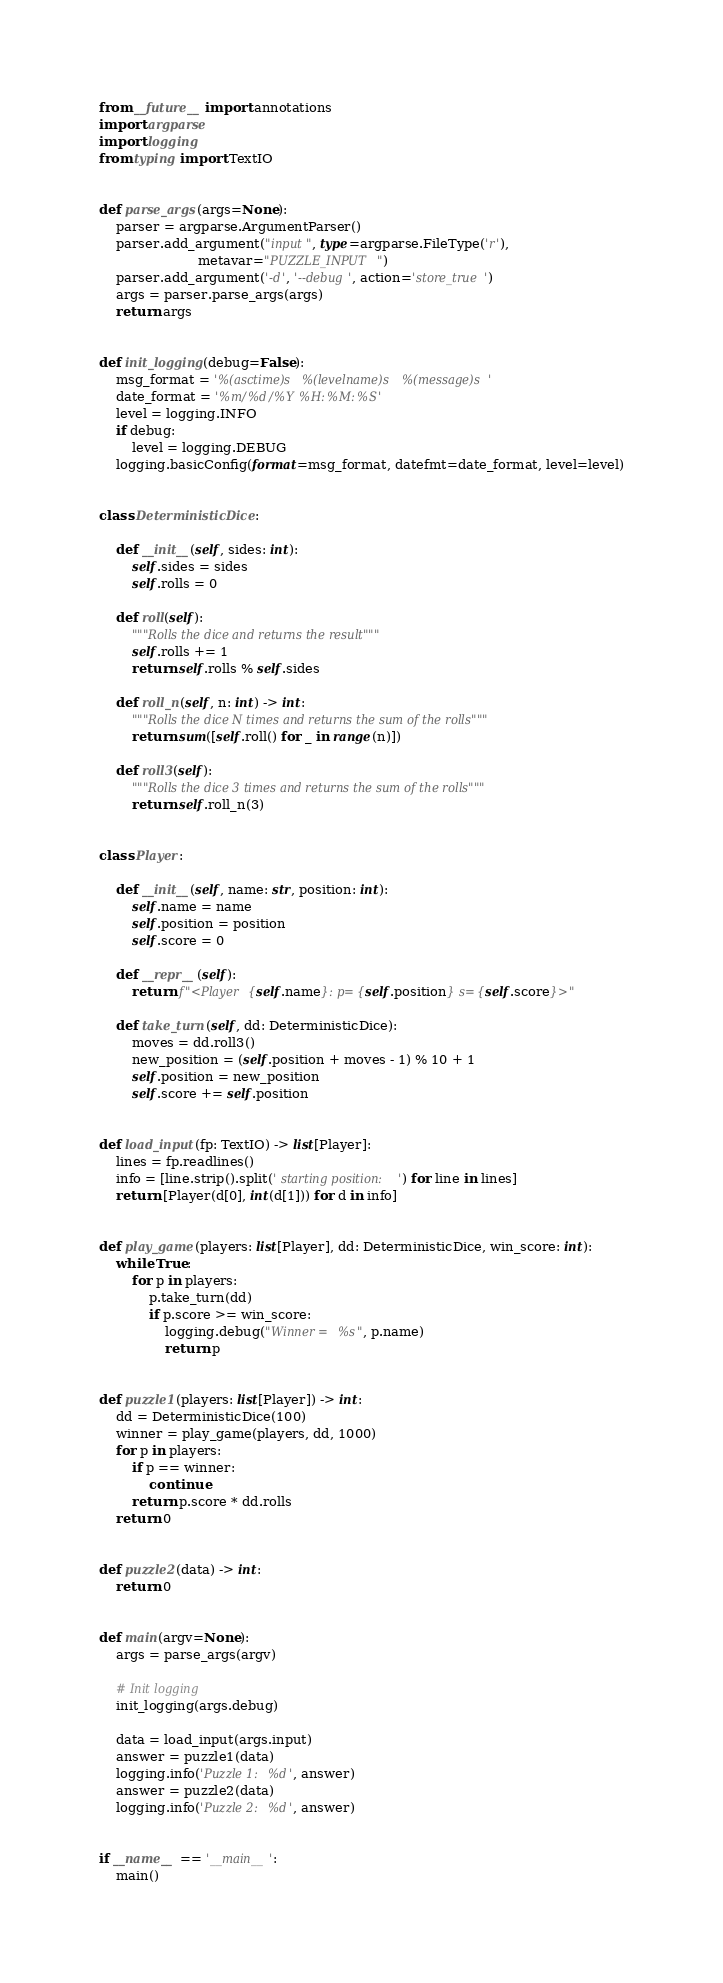<code> <loc_0><loc_0><loc_500><loc_500><_Python_>from __future__ import annotations
import argparse
import logging
from typing import TextIO


def parse_args(args=None):
    parser = argparse.ArgumentParser()
    parser.add_argument("input", type=argparse.FileType('r'),
                        metavar="PUZZLE_INPUT")
    parser.add_argument('-d', '--debug', action='store_true')
    args = parser.parse_args(args)
    return args


def init_logging(debug=False):
    msg_format = '%(asctime)s %(levelname)s %(message)s'
    date_format = '%m/%d/%Y %H:%M:%S'
    level = logging.INFO
    if debug:
        level = logging.DEBUG
    logging.basicConfig(format=msg_format, datefmt=date_format, level=level)


class DeterministicDice:

    def __init__(self, sides: int):
        self.sides = sides
        self.rolls = 0

    def roll(self):
        """Rolls the dice and returns the result"""
        self.rolls += 1
        return self.rolls % self.sides

    def roll_n(self, n: int) -> int:
        """Rolls the dice N times and returns the sum of the rolls"""
        return sum([self.roll() for _ in range(n)])

    def roll3(self):
        """Rolls the dice 3 times and returns the sum of the rolls"""
        return self.roll_n(3)


class Player:

    def __init__(self, name: str, position: int):
        self.name = name
        self.position = position
        self.score = 0

    def __repr__(self):
        return f"<Player {self.name}: p={self.position} s={self.score}>"

    def take_turn(self, dd: DeterministicDice):
        moves = dd.roll3()
        new_position = (self.position + moves - 1) % 10 + 1
        self.position = new_position
        self.score += self.position


def load_input(fp: TextIO) -> list[Player]:
    lines = fp.readlines()
    info = [line.strip().split(' starting position: ') for line in lines]
    return [Player(d[0], int(d[1])) for d in info]


def play_game(players: list[Player], dd: DeterministicDice, win_score: int):
    while True:
        for p in players:
            p.take_turn(dd)
            if p.score >= win_score:
                logging.debug("Winner = %s", p.name)
                return p


def puzzle1(players: list[Player]) -> int:
    dd = DeterministicDice(100)
    winner = play_game(players, dd, 1000)
    for p in players:
        if p == winner:
            continue
        return p.score * dd.rolls
    return 0


def puzzle2(data) -> int:
    return 0


def main(argv=None):
    args = parse_args(argv)

    # Init logging
    init_logging(args.debug)

    data = load_input(args.input)
    answer = puzzle1(data)
    logging.info('Puzzle 1: %d', answer)
    answer = puzzle2(data)
    logging.info('Puzzle 2: %d', answer)


if __name__ == '__main__':
    main()
</code> 